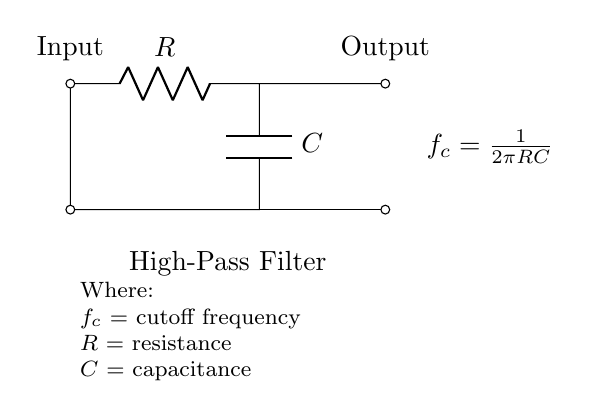What is the resistance symbol in the circuit? The resistance symbol is represented by the letter R in the circuit diagram. It indicates the resistor which impedes current flow.
Answer: R What does the capacitor symbol look like in this diagram? The capacitor is represented by a pair of parallel lines. In the diagram, it is the component labeled C, indicating its function to store charge.
Answer: C How many components are in this high-pass filter circuit? There are two components in this circuit: one resistor and one capacitor, making a total of two essential components involved.
Answer: 2 What is the purpose of the high-pass filter shown here? The purpose of the high-pass filter is to allow signals with a frequency higher than the cutoff frequency to pass through, enhancing the bass response by filtering out lower frequencies.
Answer: To allow high frequencies What is the formula for cutoff frequency in this circuit? The cutoff frequency formula displayed in the circuit is f_c = 1/(2πRC). This equation indicates how the cutoff frequency is calculated based on the values of resistance and capacitance in the circuit.
Answer: f_c = 1/(2πRC) If the resistance is doubled, what happens to the cutoff frequency? If the resistance is doubled, the cutoff frequency will be halved because the formula indicates an inverse relationship between resistance and cutoff frequency. Therefore, increasing R decreases f_c.
Answer: Cutoff frequency decreases What does increasing capacitance do to the cutoff frequency? Increasing capacitance will decrease the cutoff frequency since the cutoff frequency is inversely proportional to capacitance. Thus, a larger capacitor allows lower frequencies to pass through more easily.
Answer: Cutoff frequency decreases 